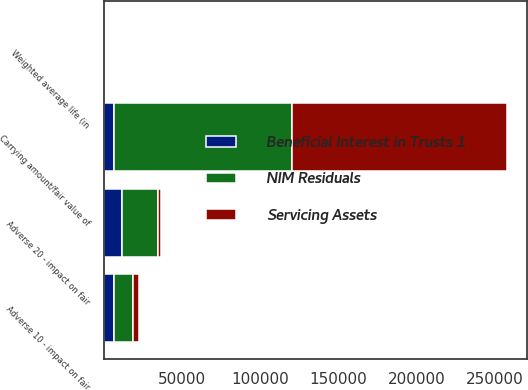<chart> <loc_0><loc_0><loc_500><loc_500><stacked_bar_chart><ecel><fcel>Carrying amount/fair value of<fcel>Weighted average life (in<fcel>Adverse 10 - impact on fair<fcel>Adverse 20 - impact on fair<nl><fcel>Beneficial Interest in Trusts 1<fcel>6352<fcel>1.4<fcel>6352<fcel>11458<nl><fcel>Servicing Assets<fcel>137757<fcel>2.2<fcel>3836<fcel>1967<nl><fcel>NIM Residuals<fcel>113821<fcel>1.2<fcel>12239<fcel>23003<nl></chart> 